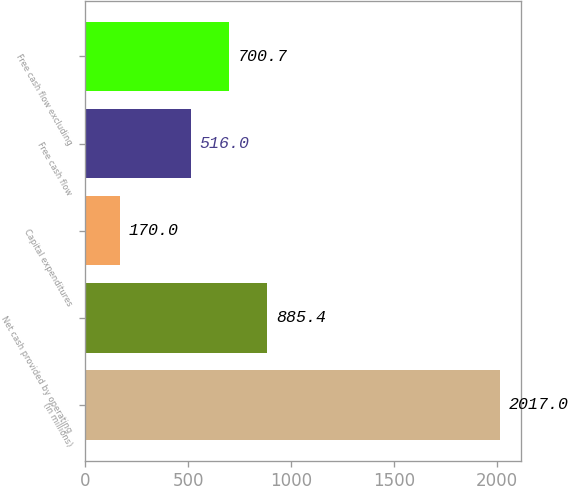Convert chart to OTSL. <chart><loc_0><loc_0><loc_500><loc_500><bar_chart><fcel>(in millions)<fcel>Net cash provided by operating<fcel>Capital expenditures<fcel>Free cash flow<fcel>Free cash flow excluding<nl><fcel>2017<fcel>885.4<fcel>170<fcel>516<fcel>700.7<nl></chart> 